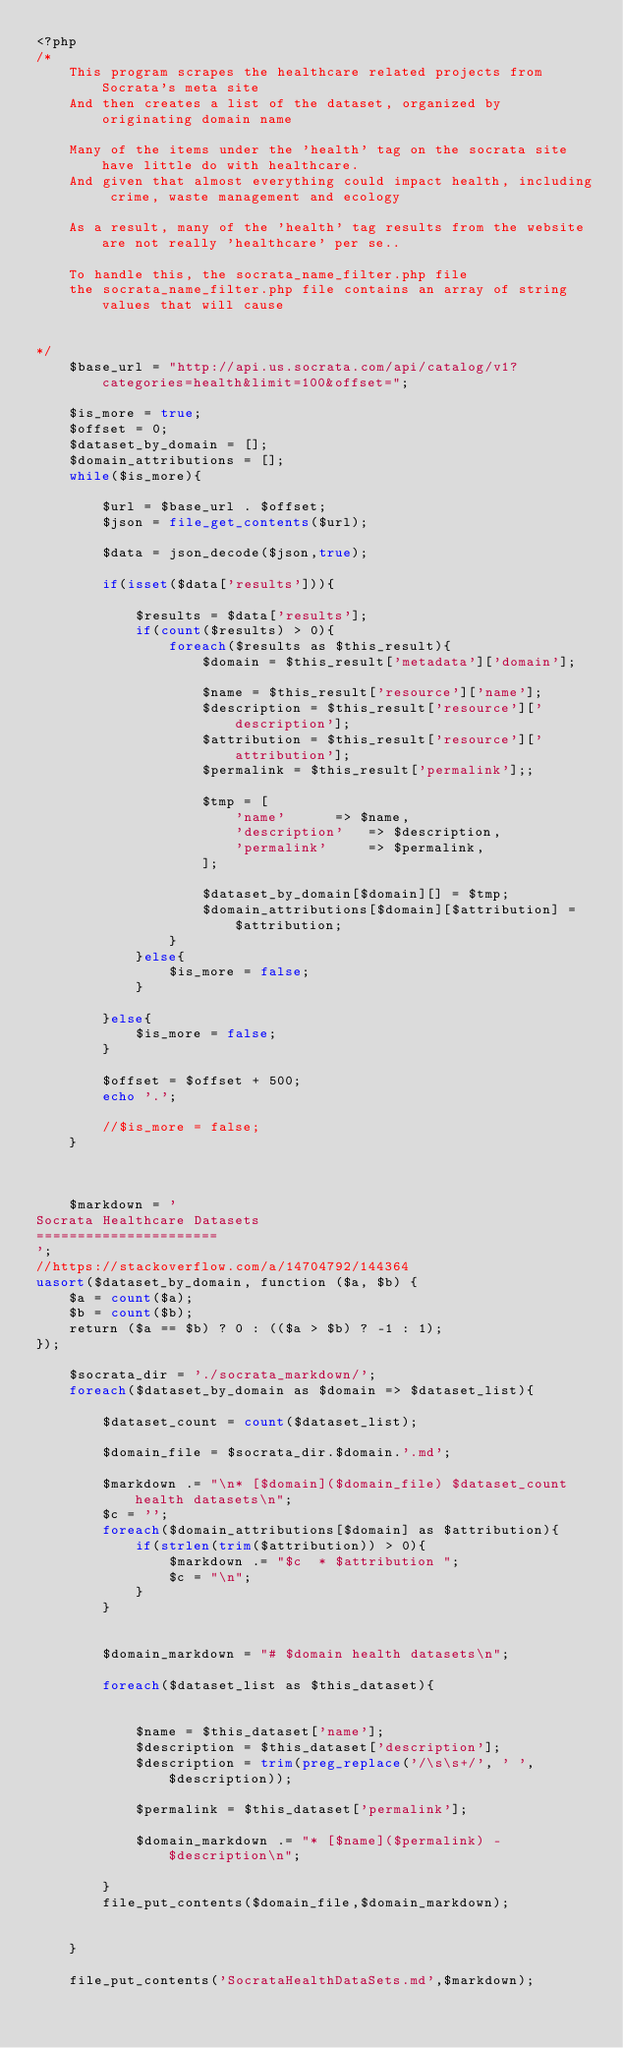Convert code to text. <code><loc_0><loc_0><loc_500><loc_500><_PHP_><?php
/*
	This program scrapes the healthcare related projects from Socrata's meta site
	And then creates a list of the dataset, organized by originating domain name

	Many of the items under the 'health' tag on the socrata site have little do with healthcare. 
	And given that almost everything could impact health, including crime, waste management and ecology
	
	As a result, many of the 'health' tag results from the website are not really 'healthcare' per se..
	
	To handle this, the socrata_name_filter.php file 
	the socrata_name_filter.php file contains an array of string values that will cause 
	

*/
	$base_url = "http://api.us.socrata.com/api/catalog/v1?categories=health&limit=100&offset=";

	$is_more = true;
	$offset = 0;
	$dataset_by_domain = [];
	$domain_attributions = [];
	while($is_more){

		$url = $base_url . $offset;
		$json = file_get_contents($url);

		$data = json_decode($json,true);

		if(isset($data['results'])){

			$results = $data['results'];
			if(count($results) > 0){
				foreach($results as $this_result){
					$domain = $this_result['metadata']['domain'];

					$name = $this_result['resource']['name'];
					$description = $this_result['resource']['description'];
					$attribution = $this_result['resource']['attribution'];
					$permalink = $this_result['permalink'];;

					$tmp = [
						'name' 		=> $name,
						'description' 	=> $description,
						'permalink' 	=> $permalink,
					];

					$dataset_by_domain[$domain][] = $tmp;
					$domain_attributions[$domain][$attribution] = $attribution;
				}
			}else{
				$is_more = false;
			}

		}else{
			$is_more = false;
		}

		$offset = $offset + 500;
		echo '.';

		//$is_more = false;
	}



	$markdown = '
Socrata Healthcare Datasets
======================
';
//https://stackoverflow.com/a/14704792/144364
uasort($dataset_by_domain, function ($a, $b) {
    $a = count($a);
    $b = count($b);
    return ($a == $b) ? 0 : (($a > $b) ? -1 : 1);
});

	$socrata_dir = './socrata_markdown/';
	foreach($dataset_by_domain as $domain => $dataset_list){

		$dataset_count = count($dataset_list);

		$domain_file = $socrata_dir.$domain.'.md';

		$markdown .= "\n* [$domain]($domain_file) $dataset_count health datasets\n";
		$c = '';
		foreach($domain_attributions[$domain] as $attribution){
			if(strlen(trim($attribution)) > 0){	
				$markdown .= "$c  * $attribution ";
				$c = "\n";
			}
		}


		$domain_markdown = "# $domain health datasets\n";
	
		foreach($dataset_list as $this_dataset){

		
			$name = $this_dataset['name'];
			$description = $this_dataset['description'];
			$description = trim(preg_replace('/\s\s+/', ' ', $description));

			$permalink = $this_dataset['permalink'];

			$domain_markdown .= "* [$name]($permalink) - $description\n";
	
		}
		file_put_contents($domain_file,$domain_markdown);
		

	}

	file_put_contents('SocrataHealthDataSets.md',$markdown);

</code> 